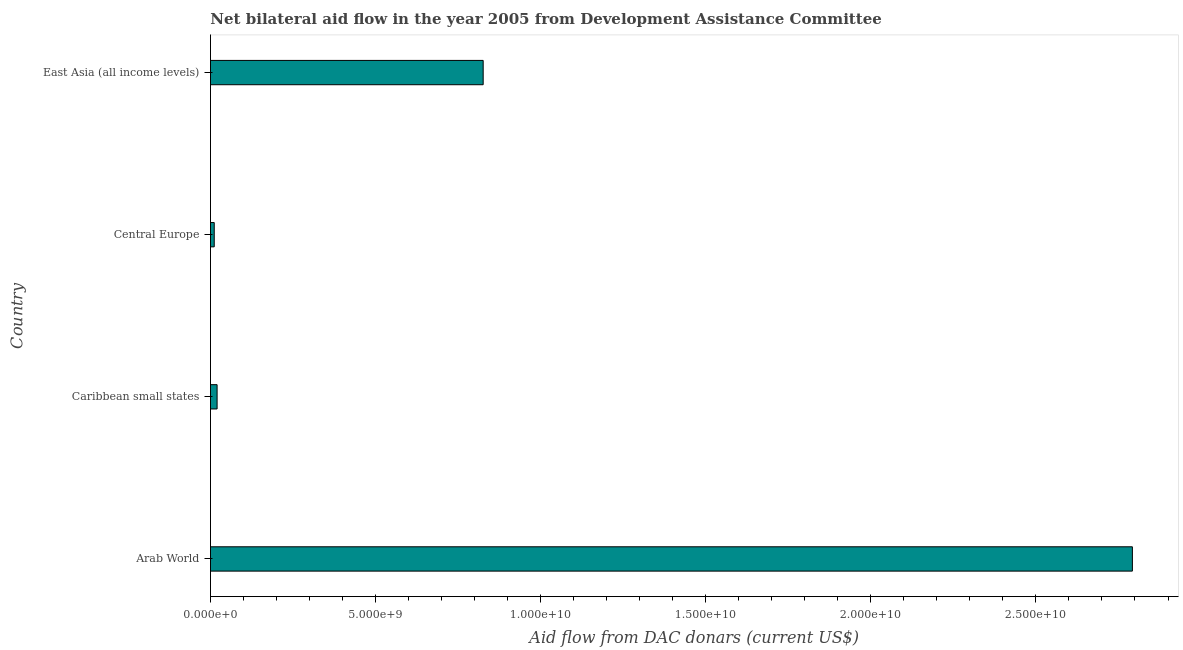Does the graph contain grids?
Provide a succinct answer. No. What is the title of the graph?
Your answer should be very brief. Net bilateral aid flow in the year 2005 from Development Assistance Committee. What is the label or title of the X-axis?
Your answer should be very brief. Aid flow from DAC donars (current US$). What is the label or title of the Y-axis?
Keep it short and to the point. Country. What is the net bilateral aid flows from dac donors in Caribbean small states?
Give a very brief answer. 2.01e+08. Across all countries, what is the maximum net bilateral aid flows from dac donors?
Offer a very short reply. 2.79e+1. Across all countries, what is the minimum net bilateral aid flows from dac donors?
Offer a very short reply. 1.14e+08. In which country was the net bilateral aid flows from dac donors maximum?
Your answer should be very brief. Arab World. In which country was the net bilateral aid flows from dac donors minimum?
Make the answer very short. Central Europe. What is the sum of the net bilateral aid flows from dac donors?
Give a very brief answer. 3.65e+1. What is the difference between the net bilateral aid flows from dac donors in Central Europe and East Asia (all income levels)?
Provide a short and direct response. -8.14e+09. What is the average net bilateral aid flows from dac donors per country?
Give a very brief answer. 9.12e+09. What is the median net bilateral aid flows from dac donors?
Ensure brevity in your answer.  4.23e+09. What is the ratio of the net bilateral aid flows from dac donors in Arab World to that in Central Europe?
Keep it short and to the point. 244.71. Is the net bilateral aid flows from dac donors in Central Europe less than that in East Asia (all income levels)?
Provide a short and direct response. Yes. What is the difference between the highest and the second highest net bilateral aid flows from dac donors?
Offer a terse response. 1.97e+1. What is the difference between the highest and the lowest net bilateral aid flows from dac donors?
Keep it short and to the point. 2.78e+1. Are all the bars in the graph horizontal?
Provide a succinct answer. Yes. How many countries are there in the graph?
Offer a very short reply. 4. What is the difference between two consecutive major ticks on the X-axis?
Keep it short and to the point. 5.00e+09. What is the Aid flow from DAC donars (current US$) in Arab World?
Your answer should be very brief. 2.79e+1. What is the Aid flow from DAC donars (current US$) of Caribbean small states?
Give a very brief answer. 2.01e+08. What is the Aid flow from DAC donars (current US$) in Central Europe?
Give a very brief answer. 1.14e+08. What is the Aid flow from DAC donars (current US$) of East Asia (all income levels)?
Provide a short and direct response. 8.26e+09. What is the difference between the Aid flow from DAC donars (current US$) in Arab World and Caribbean small states?
Offer a very short reply. 2.77e+1. What is the difference between the Aid flow from DAC donars (current US$) in Arab World and Central Europe?
Ensure brevity in your answer.  2.78e+1. What is the difference between the Aid flow from DAC donars (current US$) in Arab World and East Asia (all income levels)?
Provide a succinct answer. 1.97e+1. What is the difference between the Aid flow from DAC donars (current US$) in Caribbean small states and Central Europe?
Give a very brief answer. 8.66e+07. What is the difference between the Aid flow from DAC donars (current US$) in Caribbean small states and East Asia (all income levels)?
Make the answer very short. -8.06e+09. What is the difference between the Aid flow from DAC donars (current US$) in Central Europe and East Asia (all income levels)?
Offer a terse response. -8.14e+09. What is the ratio of the Aid flow from DAC donars (current US$) in Arab World to that in Caribbean small states?
Offer a very short reply. 139.15. What is the ratio of the Aid flow from DAC donars (current US$) in Arab World to that in Central Europe?
Your response must be concise. 244.71. What is the ratio of the Aid flow from DAC donars (current US$) in Arab World to that in East Asia (all income levels)?
Make the answer very short. 3.38. What is the ratio of the Aid flow from DAC donars (current US$) in Caribbean small states to that in Central Europe?
Offer a very short reply. 1.76. What is the ratio of the Aid flow from DAC donars (current US$) in Caribbean small states to that in East Asia (all income levels)?
Offer a terse response. 0.02. What is the ratio of the Aid flow from DAC donars (current US$) in Central Europe to that in East Asia (all income levels)?
Provide a short and direct response. 0.01. 